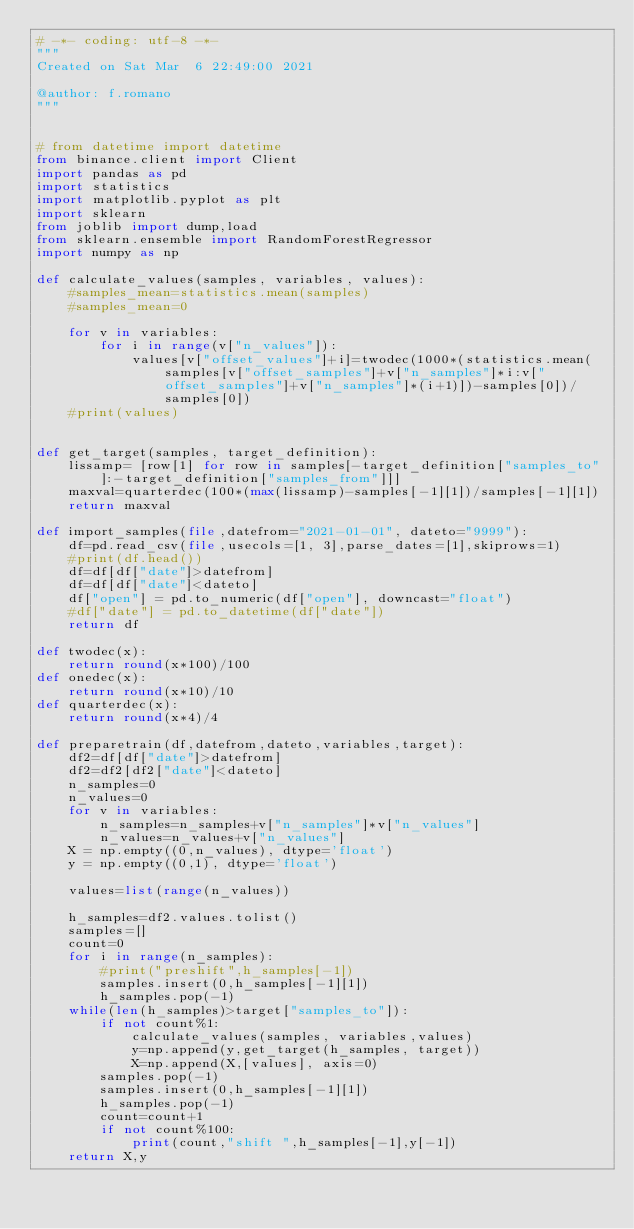<code> <loc_0><loc_0><loc_500><loc_500><_Python_># -*- coding: utf-8 -*-
"""
Created on Sat Mar  6 22:49:00 2021

@author: f.romano
"""


# from datetime import datetime
from binance.client import Client
import pandas as pd
import statistics 
import matplotlib.pyplot as plt
import sklearn
from joblib import dump,load
from sklearn.ensemble import RandomForestRegressor
import numpy as np

def calculate_values(samples, variables, values):
    #samples_mean=statistics.mean(samples)
    #samples_mean=0
    
    for v in variables:
        for i in range(v["n_values"]):
            values[v["offset_values"]+i]=twodec(1000*(statistics.mean(samples[v["offset_samples"]+v["n_samples"]*i:v["offset_samples"]+v["n_samples"]*(i+1)])-samples[0])/samples[0])
    #print(values)


def get_target(samples, target_definition):
    lissamp= [row[1] for row in samples[-target_definition["samples_to"]:-target_definition["samples_from"]]]
    maxval=quarterdec(100*(max(lissamp)-samples[-1][1])/samples[-1][1])
    return maxval

def import_samples(file,datefrom="2021-01-01", dateto="9999"):
    df=pd.read_csv(file,usecols=[1, 3],parse_dates=[1],skiprows=1)
    #print(df.head())
    df=df[df["date"]>datefrom]  
    df=df[df["date"]<dateto]
    df["open"] = pd.to_numeric(df["open"], downcast="float")
    #df["date"] = pd.to_datetime(df["date"])
    return df

def twodec(x):
    return round(x*100)/100
def onedec(x):
    return round(x*10)/10
def quarterdec(x):
    return round(x*4)/4

def preparetrain(df,datefrom,dateto,variables,target):
    df2=df[df["date"]>datefrom]  
    df2=df2[df2["date"]<dateto]
    n_samples=0
    n_values=0
    for v in variables:
        n_samples=n_samples+v["n_samples"]*v["n_values"]
        n_values=n_values+v["n_values"]
    X = np.empty((0,n_values), dtype='float')
    y = np.empty((0,1), dtype='float')
    
    values=list(range(n_values))

    h_samples=df2.values.tolist()
    samples=[]
    count=0
    for i in range(n_samples):
        #print("preshift",h_samples[-1])
        samples.insert(0,h_samples[-1][1])
        h_samples.pop(-1)
    while(len(h_samples)>target["samples_to"]):
        if not count%1:
            calculate_values(samples, variables,values)
            y=np.append(y,get_target(h_samples, target))
            X=np.append(X,[values], axis=0)
        samples.pop(-1)
        samples.insert(0,h_samples[-1][1]) 
        h_samples.pop(-1)
        count=count+1
        if not count%100:
            print(count,"shift ",h_samples[-1],y[-1])
    return X,y</code> 